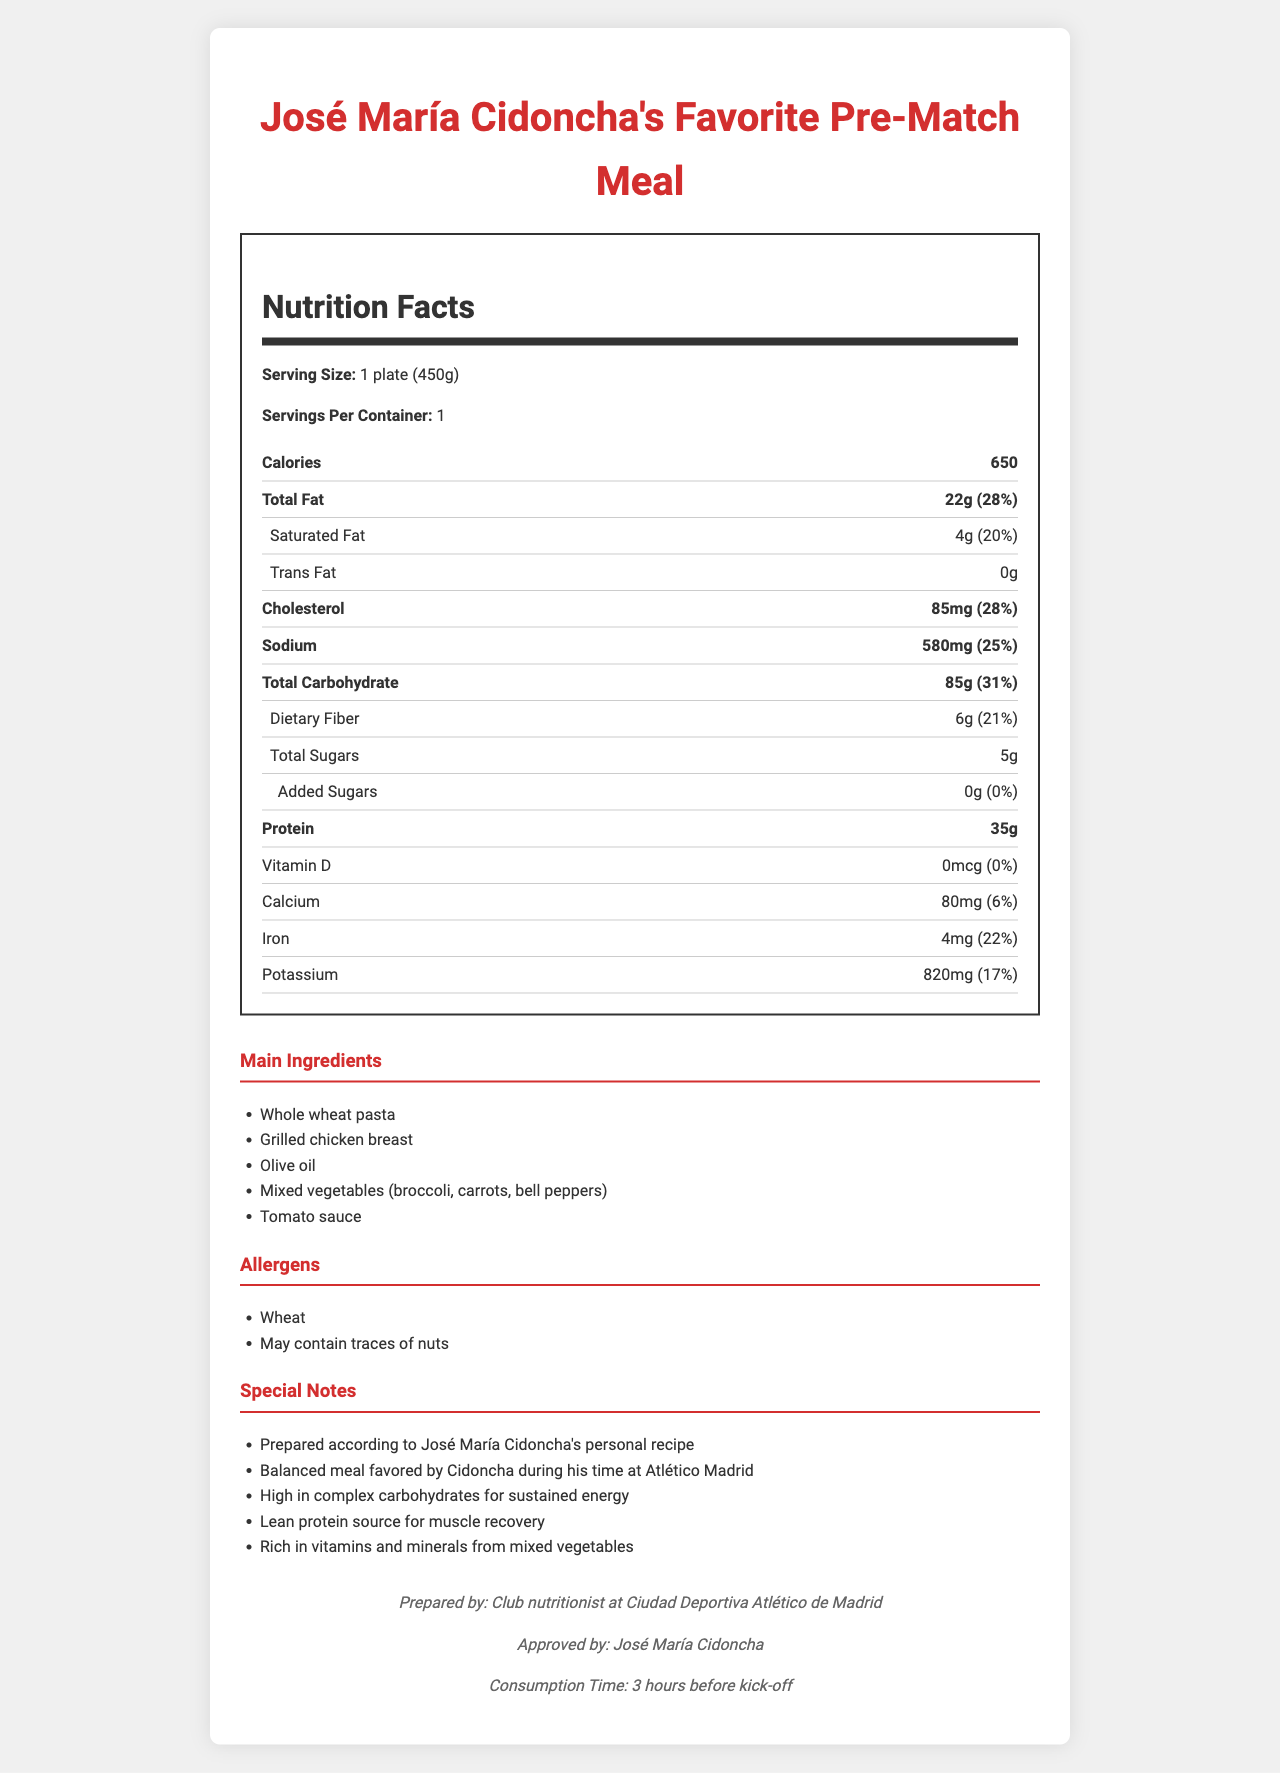what is the serving size? The serving size is explicitly mentioned as 1 plate (450g) in the document.
Answer: 1 plate (450g) how many calories are in one serving of José María Cidoncha's favorite pre-match meal? The document states that there are 650 calories in one serving.
Answer: 650 what percentage of the daily value of sodium does one serving provide? The daily value percentage for sodium is listed as 25%.
Answer: 25% is there any added sugar in this meal? The document states that the amount of added sugars is 0g, with a daily value percentage of 0%.
Answer: No list two main ingredients in José María Cidoncha's favorite pre-match meal. The main ingredients listed include Whole wheat pasta, Grilled chicken breast among others.
Answer: Whole wheat pasta, Grilled chicken breast how much protein does one serving contain? It is specified that one serving contains 35g of protein.
Answer: 35g how much iron does this meal contribute to the daily value? A. 6% B. 17% C. 22% D. 28% The document shows that the iron content provides 22% of the daily value, which matches option C.
Answer: C what type of dietary fat is not present in this meal? A. Total Fat B. Saturated Fat C. Trans Fat The table shows that trans fat amount is 0g, which matches option C.
Answer: C is this meal approved by José María Cidoncha? The document explicitly mentions that the meal is approved by José María Cidoncha.
Answer: Yes describe the main idea of this document. The description includes details about the nutritional values, key ingredients, allergen information, special notes about the recipe's benefits, and its preparation and approval by José María Cidoncha.
Answer: It provides the nutritional information, ingredients, allergens, and special notes for José María Cidoncha's favorite pre-match meal, which is designed to provide balanced nutrition to sustain energy, and aid muscle recovery, particularly during his time at Atlético Madrid. who prepared the meal? The document specifies the meal is prepared by the club nutritionist at Ciudad Deportiva Atlético de Madrid, but it doesn't provide a specific name, so the detailed individual preparing the meal cannot be determined.
Answer: Cannot be determined how many grams of dietary fiber are in one serving? The nutritional information indicates that one serving contains 6g of dietary fiber.
Answer: 6g what is the percentage of daily value for carbohydrates provided by this meal? The document lists that the total carbohydrate content provides 31% of the daily value.
Answer: 31% are there any potential allergens in this meal? The document mentions that the meal contains wheat and may contain traces of nuts as potential allergens.
Answer: Yes how many milligrams of potassium does this meal contain? The nutritional section indicates that the meal contains 820mg of potassium.
Answer: 820mg 